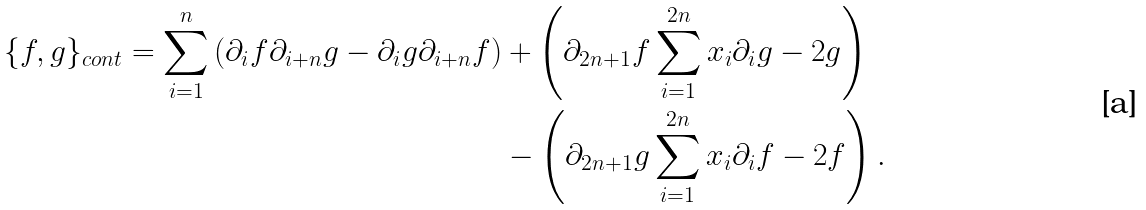<formula> <loc_0><loc_0><loc_500><loc_500>\{ f , g \} _ { c o n t } = \sum _ { i = 1 } ^ { n } \left ( \partial _ { i } { f } \partial _ { i + n } { g } - \partial _ { i } { g } \partial _ { i + n } { f } \right ) & + \left ( \partial _ { 2 n + 1 } { f } \sum _ { i = 1 } ^ { 2 n } { x _ { i } \partial _ { i } { g } - 2 g } \right ) \\ & - \left ( \partial _ { 2 n + 1 } { g } \sum _ { i = 1 } ^ { 2 n } { x _ { i } \partial _ { i } { f } - 2 f } \right ) .</formula> 